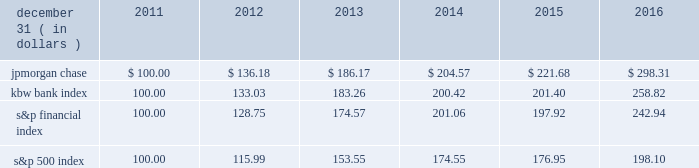Jpmorgan chase & co./2016 annual report 35 five-year stock performance the table and graph compare the five-year cumulative total return for jpmorgan chase & co .
( 201cjpmorgan chase 201d or the 201cfirm 201d ) common stock with the cumulative return of the s&p 500 index , the kbw bank index and the s&p financial index .
The s&p 500 index is a commonly referenced united states of america ( 201cu.s . 201d ) equity benchmark consisting of leading companies from different economic sectors .
The kbw bank index seeks to reflect the performance of banks and thrifts that are publicly traded in the u.s .
And is composed of leading national money center and regional banks and thrifts .
The s&p financial index is an index of financial companies , all of which are components of the s&p 500 .
The firm is a component of all three industry indices .
The table and graph assume simultaneous investments of $ 100 on december 31 , 2011 , in jpmorgan chase common stock and in each of the above indices .
The comparison assumes that all dividends are reinvested .
December 31 , ( in dollars ) 2011 2012 2013 2014 2015 2016 .
December 31 , ( in dollars ) .
Based on the review of the simultaneous investments of the jpmorgan chase common stock and in each of the above indices what was the performance ratio of the jpmorgan chase compared to kbw bank index? 
Computations: (298.31 / 258.82)
Answer: 1.15258. 